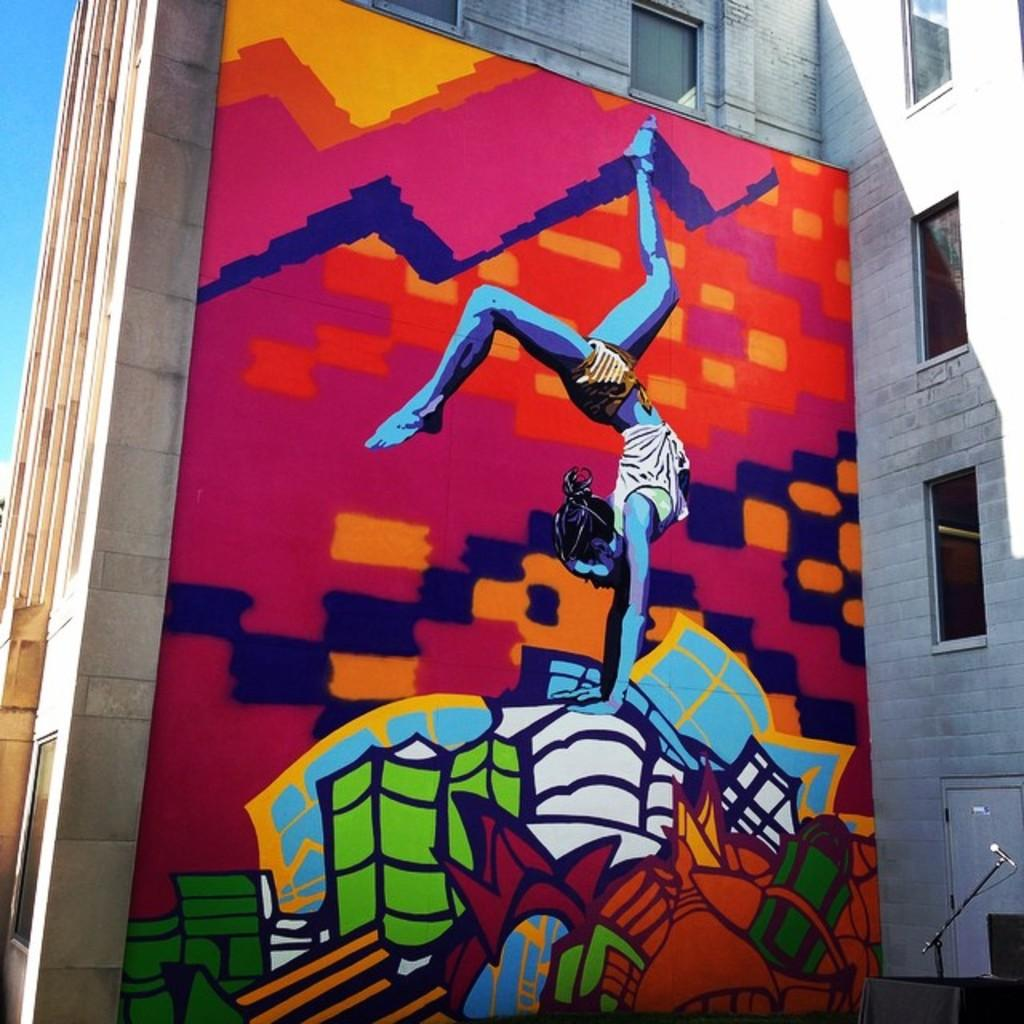What is the main subject of the picture? The main subject of the picture is a building. What can be seen on the building? There is a painting of a person on the building, as well as other objects. What is visible in the background of the picture? The sky is visible in the background of the picture. Can you tell me how many members are on the team depicted in the painting on the building? There is no team depicted in the painting on the building; it features a person. What type of scene is taking place in the painting on the building? There is no scene taking place in the painting on the building; it features a person. 